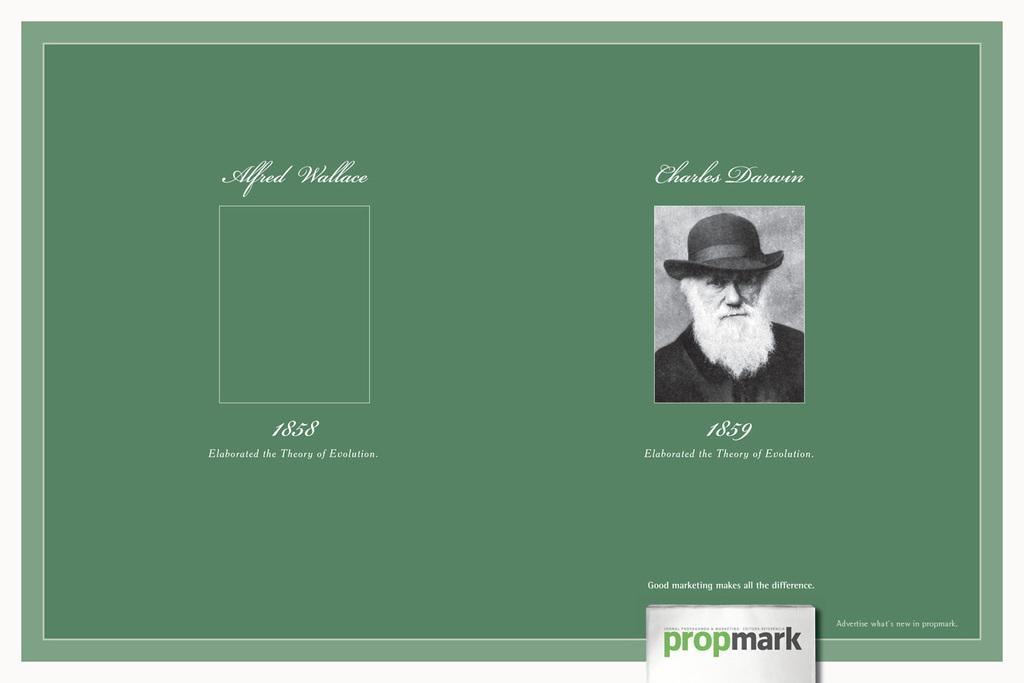Could you give a brief overview of what you see in this image? In this image we can see a photograph of a man pasted on green color sheet. And we can see some text. 